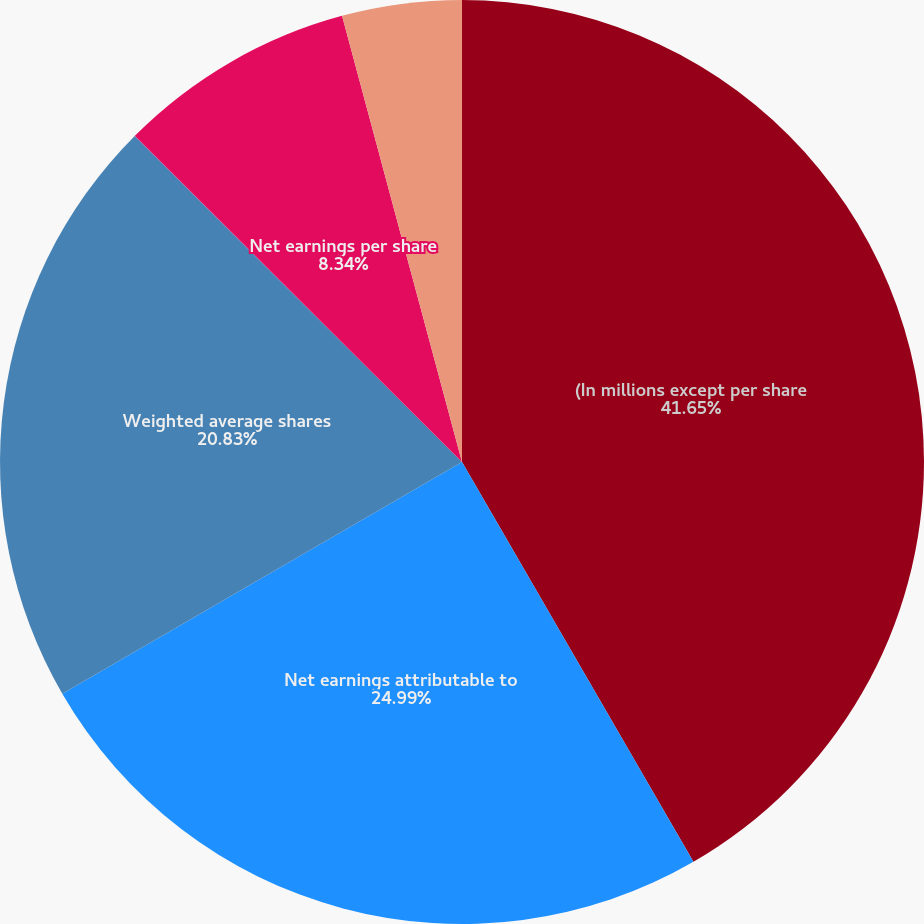Convert chart. <chart><loc_0><loc_0><loc_500><loc_500><pie_chart><fcel>(In millions except per share<fcel>Net earnings attributable to<fcel>Weighted average shares<fcel>Dilutive effect of potential<fcel>Net earnings per share<fcel>Anti-dilutive employee shared<nl><fcel>41.65%<fcel>24.99%<fcel>20.83%<fcel>0.01%<fcel>8.34%<fcel>4.18%<nl></chart> 